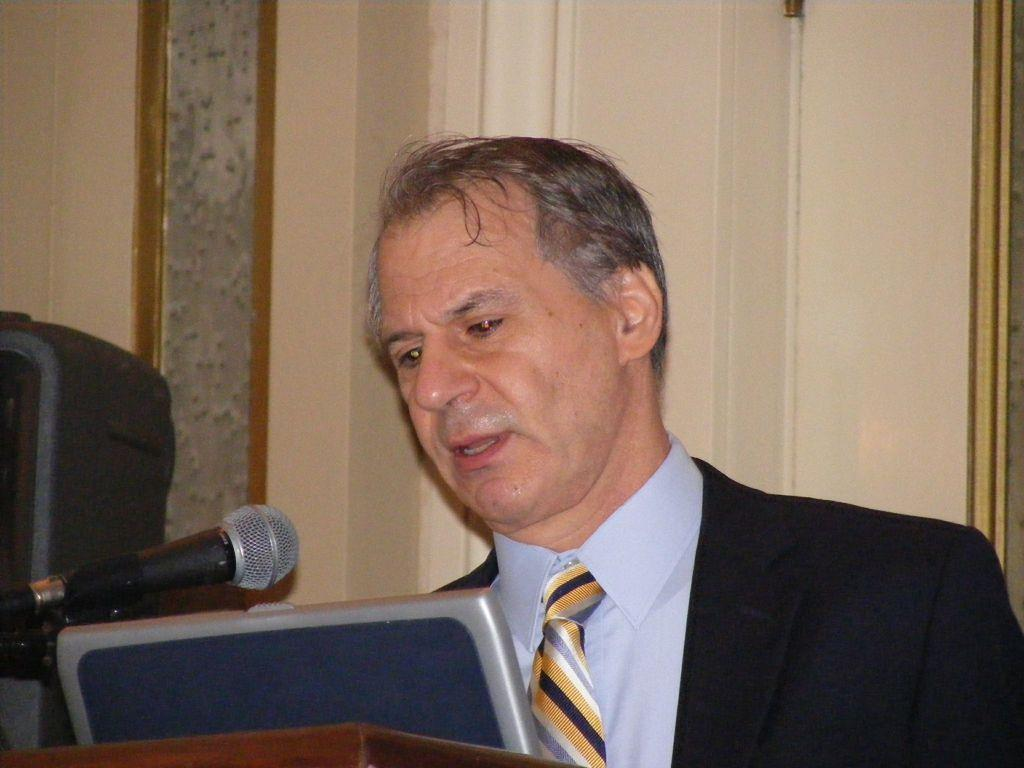Who or what is present in the image? There is a person in the image. What can be seen at the bottom left corner of the image? There are objects in the left bottom of the image. What device is visible in the image? There is a microphone in the image. What type of structure is present in the image? There is a wall in the image. What type of fear is the person experiencing in the image? There is no indication of fear in the image; the person's emotions or feelings are not visible or described. 